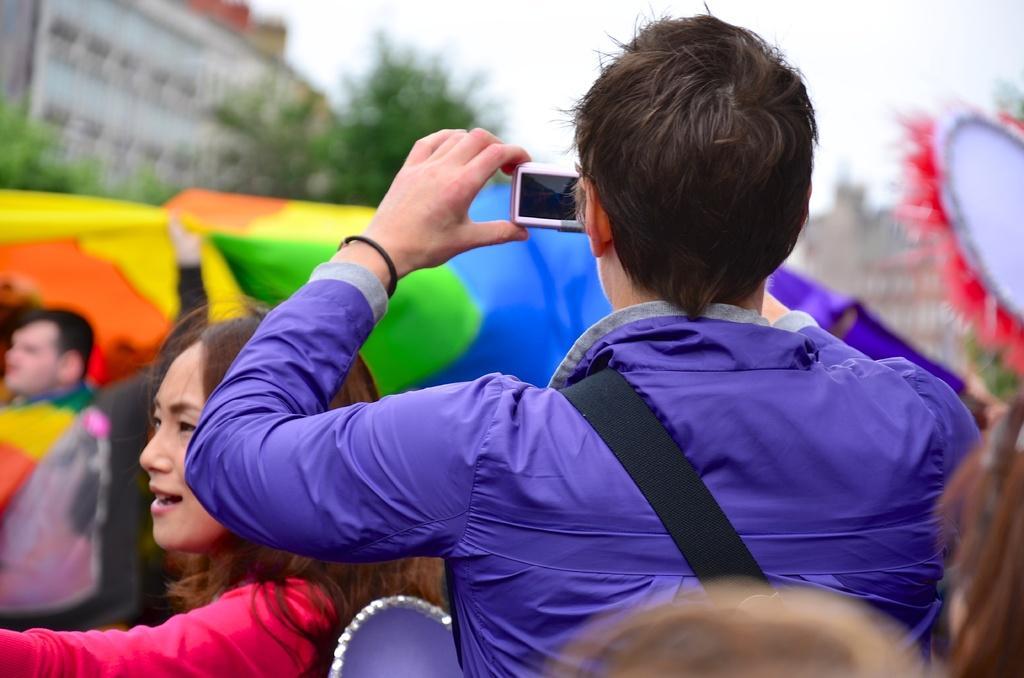Can you describe this image briefly? In the image in the center we can see one person standing and holding camera. In the background we can see the sky,clouds,buildings,trees and few people were standing and holding some objects. 